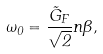Convert formula to latex. <formula><loc_0><loc_0><loc_500><loc_500>\omega _ { 0 } = \frac { { \tilde { G } } _ { F } } { \sqrt { 2 } } n \beta ,</formula> 